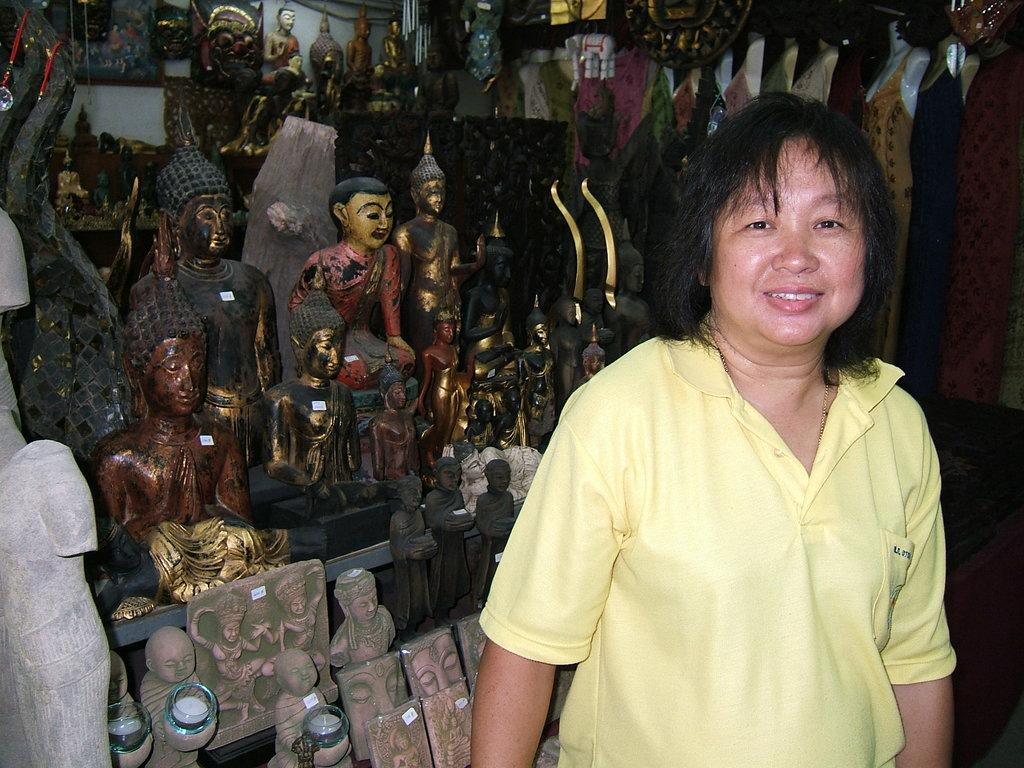Who is present in the image? There is a woman in the image. What is the woman wearing? The woman is wearing a yellow T-shirt. What can be seen in the background of the image? There are idols and sculptures in the background of the image. What is located on the right side of the image? There are dresses on the right side of the image. What type of harmony is being performed by the woman and the plane in the image? There is no plane present in the image, and therefore no such performance can be observed. 